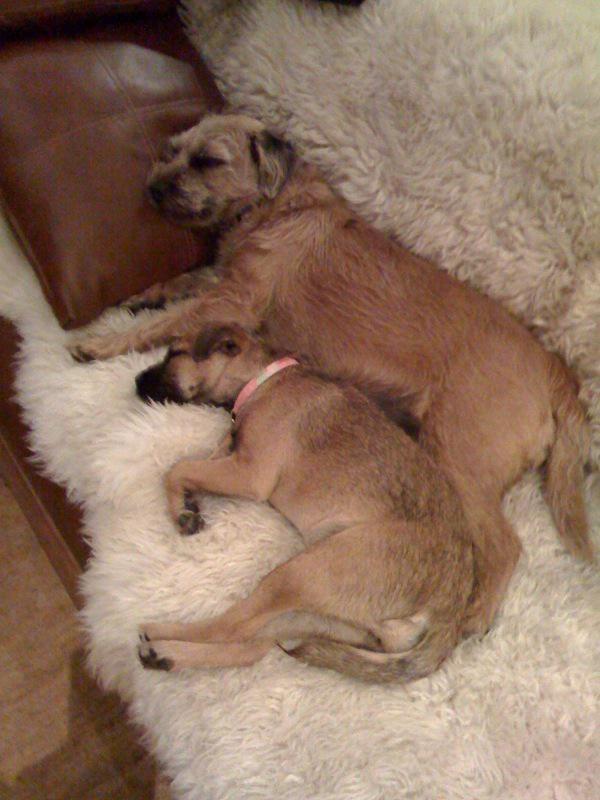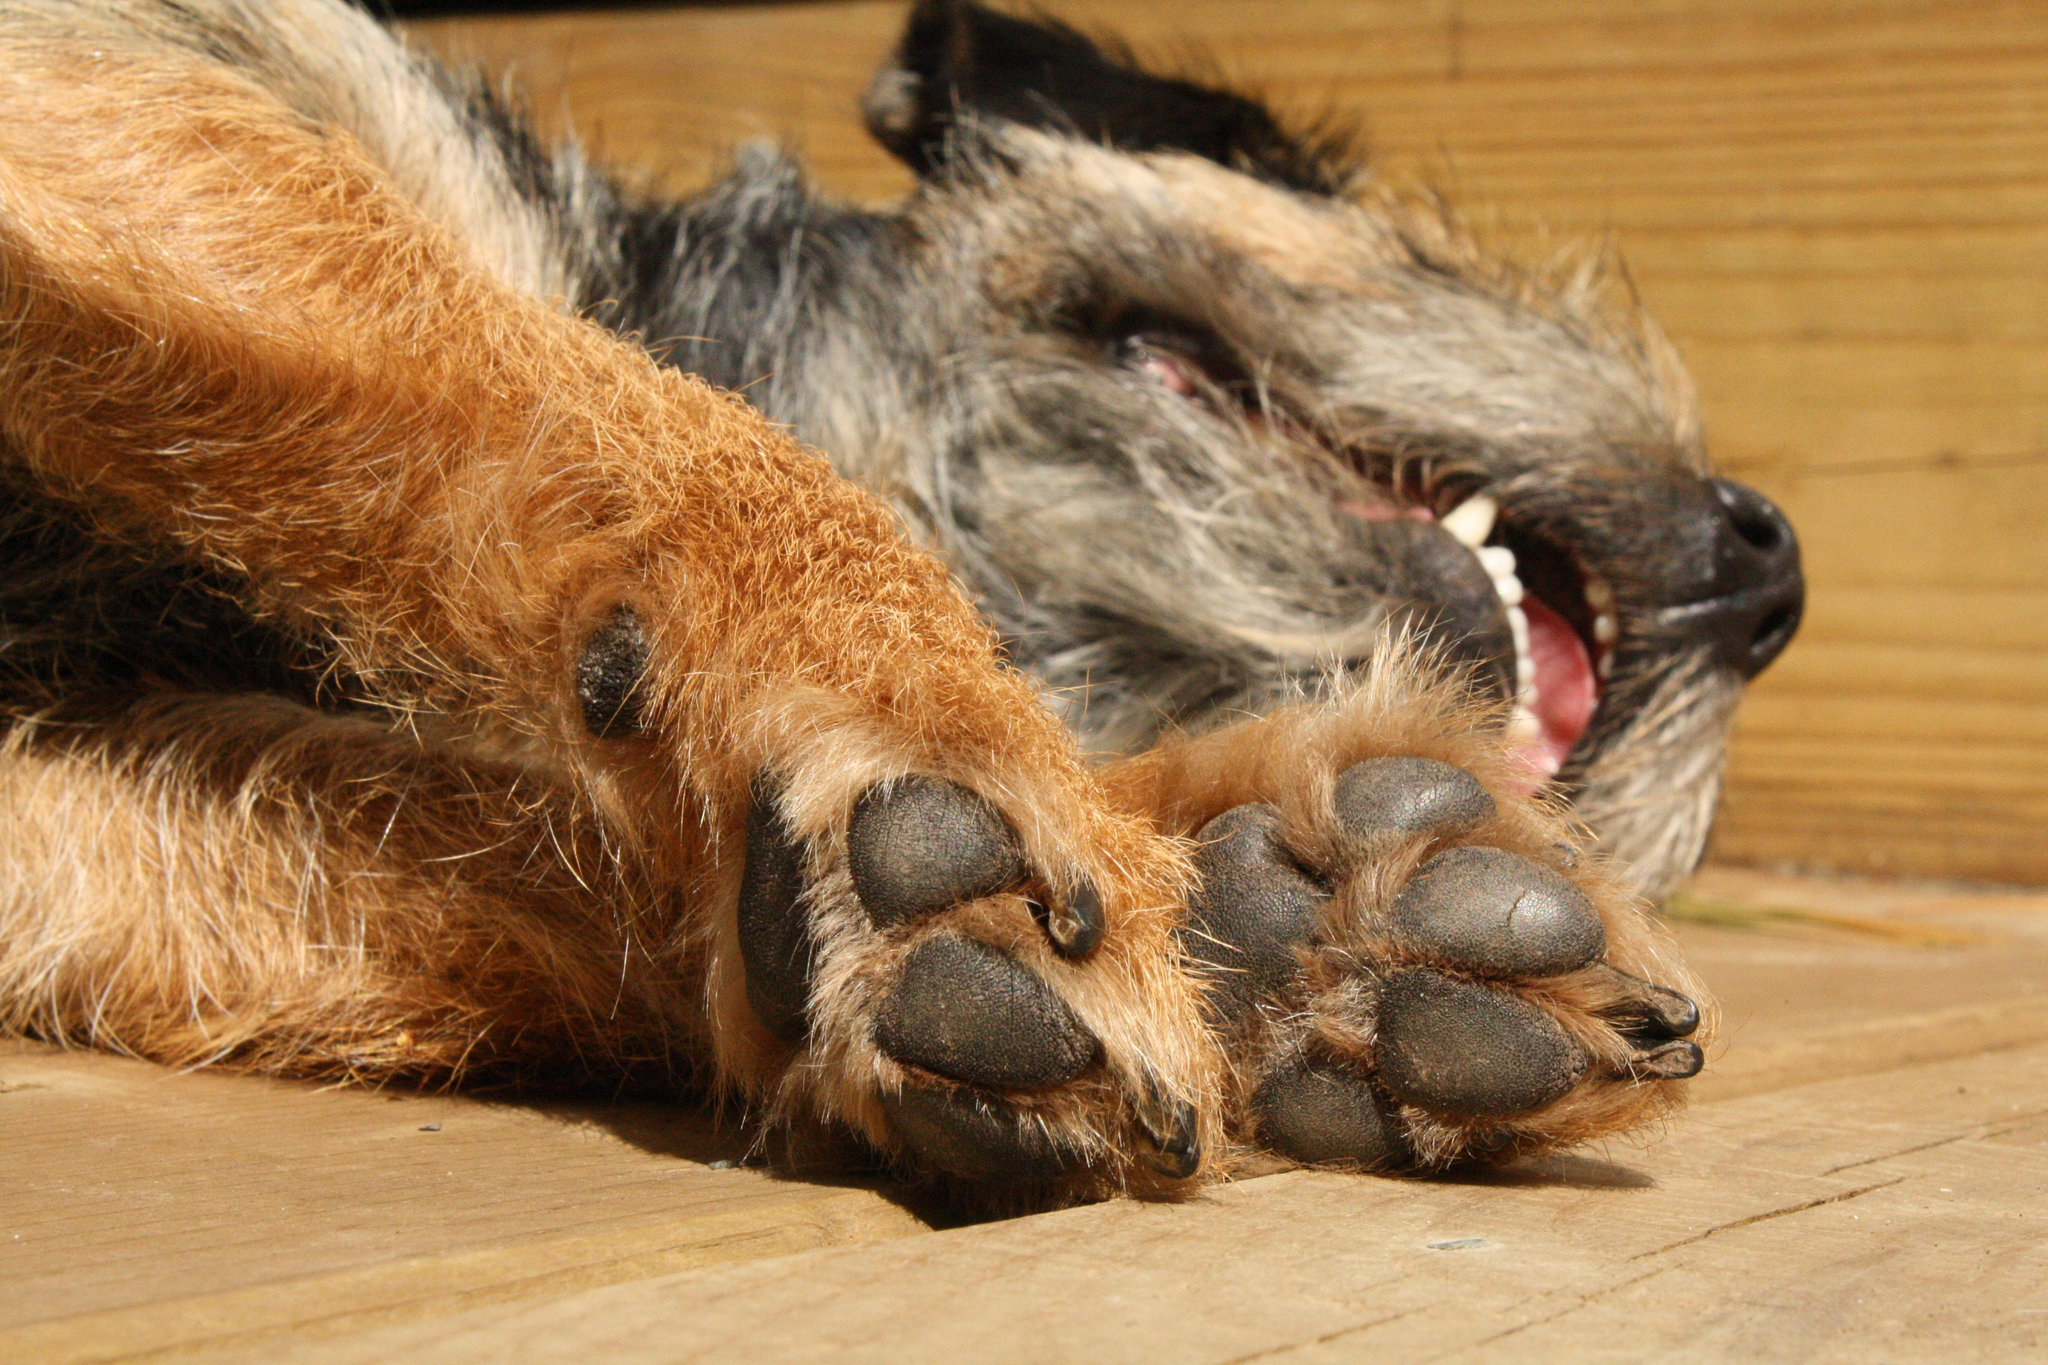The first image is the image on the left, the second image is the image on the right. Examine the images to the left and right. Is the description "There are no more than two dogs." accurate? Answer yes or no. No. The first image is the image on the left, the second image is the image on the right. Considering the images on both sides, is "There are three dogs sleeping" valid? Answer yes or no. Yes. 